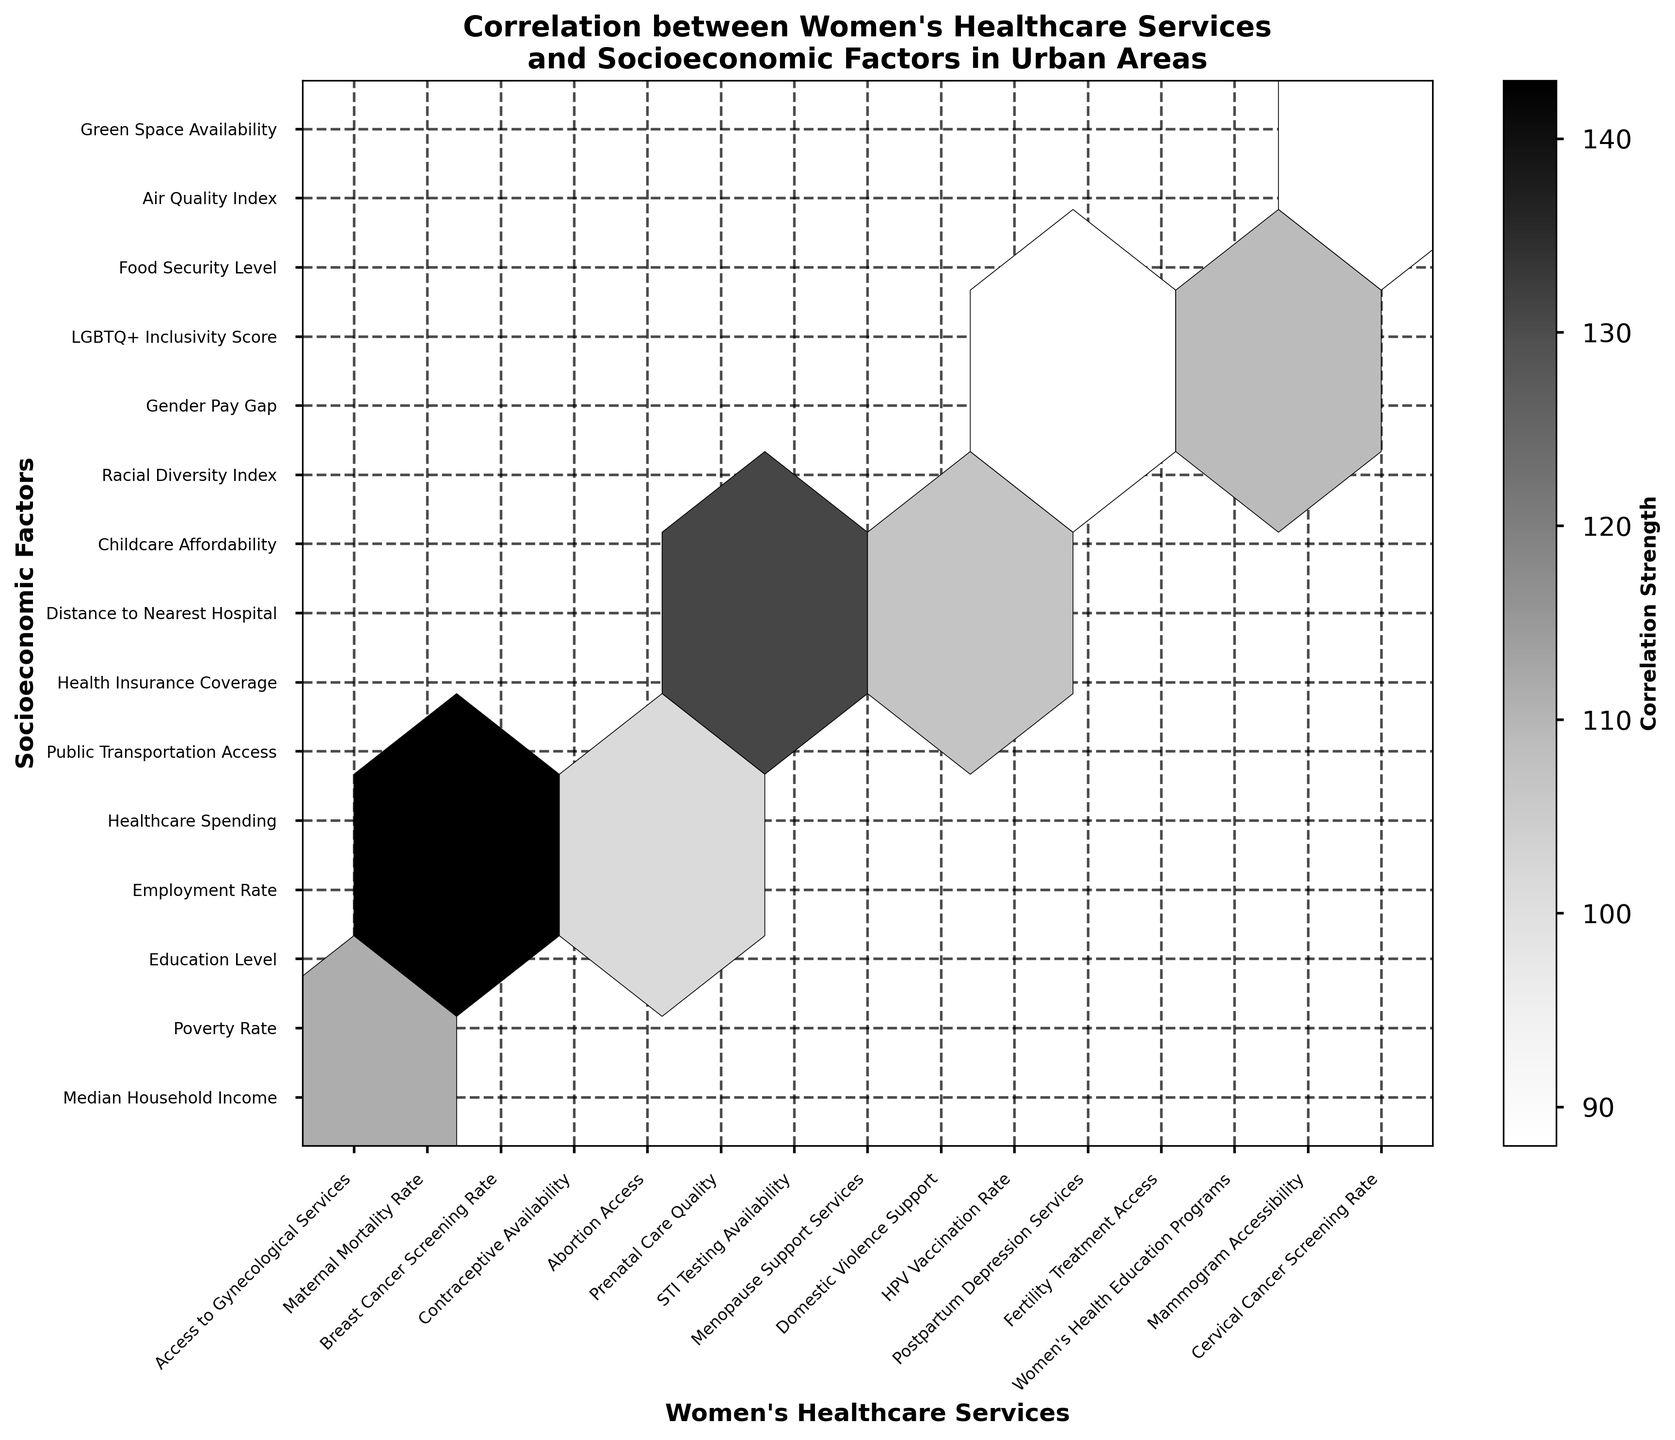What is the title of the figure? The title is usually displayed at the top of the figure to provide context about what is being shown. In this case, it is a descriptive phrase about the plot's content.
Answer: Correlation between Women's Healthcare Services and Socioeconomic Factors in Urban Areas Which socioeconomic factor is represented by the highest count in the plot? The count defines the correlation strength, and we need to look at the color bar and the hexbin plot to identify which y-axis label aligns with the highest count.
Answer: Education Level How many socioeconomic factors are compared with Women's healthcare services in the plot? Each label on the y-axis represents a different socioeconomic factor. To find the total, count the number of unique labels.
Answer: 15 What does the color intensity in the hexbin plot represent? The color bar usually indicates what the color intensities mean; darker shades in this plot depict stronger correlations.
Answer: Correlation Strength Which women's healthcare service shows a correlation with the 'Median Household Income' socioeconomic factor? Identify the x-axis label directly across the hexagon associated with 'Median Household Income' on the y-axis.
Answer: Access to Gynecological Services Which women's healthcare service is shown to have a correlation with 'Public Transportation Access'? Find the intersection on the hexbin plot that aligns with 'Public Transportation Access' on the y-axis.
Answer: Prenatal Care Quality Between 'Food Security Level' and 'Healthcare Spending', which one has a stronger correlation with women's healthcare services? Compare the hexagons aligned with 'Food Security Level' and 'Healthcare Spending' on the y-axis by examining the color intensity.
Answer: Food Security Level Which two socioeconomic factors have the closest equivalent count values of 101 and 102 (if values are present)? Locate the hexes with the count values of 101 and 102 by comparing the shade, and then identify the corresponding y-axis labels.
Answer: Racial Diversity Index and none (no exact 102 present) How are 'Domestic Violence Support' and 'Childcare Affordability' related in the context of the plot? Identify the position of 'Domestic Violence Support' on the x-axis and 'Childcare Affordability' on the y-axis and check the hexagon at their intersection.
Answer: They have a correlation indicated by the hexbin plot Which healthcare service has the least correlation with 'Gender Pay Gap' based on visual representation? Check the y-axis for 'Gender Pay Gap' and identify the healthcare service on the x-axis that intersects with the lightest color shade (lowest correlation).
Answer: Postpartum Depression Services 